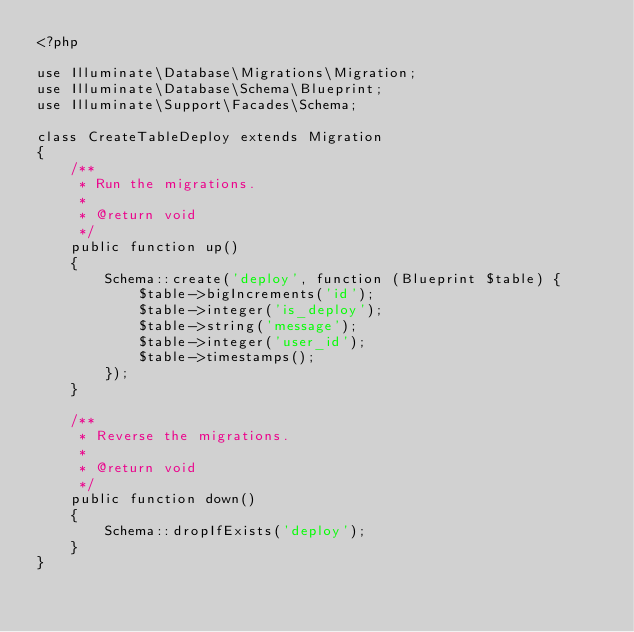Convert code to text. <code><loc_0><loc_0><loc_500><loc_500><_PHP_><?php

use Illuminate\Database\Migrations\Migration;
use Illuminate\Database\Schema\Blueprint;
use Illuminate\Support\Facades\Schema;

class CreateTableDeploy extends Migration
{
    /**
     * Run the migrations.
     *
     * @return void
     */
    public function up()
    {
        Schema::create('deploy', function (Blueprint $table) {
            $table->bigIncrements('id');
            $table->integer('is_deploy');
            $table->string('message');
            $table->integer('user_id');
            $table->timestamps();
        });
    }

    /**
     * Reverse the migrations.
     *
     * @return void
     */
    public function down()
    {
        Schema::dropIfExists('deploy');
    }
}
</code> 